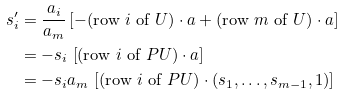Convert formula to latex. <formula><loc_0><loc_0><loc_500><loc_500>s _ { i } ^ { \prime } & = \frac { a _ { i } } { a _ { m } } \left [ - ( \text {row $i$ of $U$} ) \cdot a + ( \text {row $m$ of $U$} ) \cdot a \right ] \\ & = - s _ { i } \, \left [ ( \text {row $i$ of $PU$} ) \cdot a \right ] \\ & = - s _ { i } a _ { m } \, \left [ ( \text {row $i$ of $PU$} ) \cdot ( s _ { 1 } , \dots , s _ { m - 1 } , 1 ) \right ]</formula> 